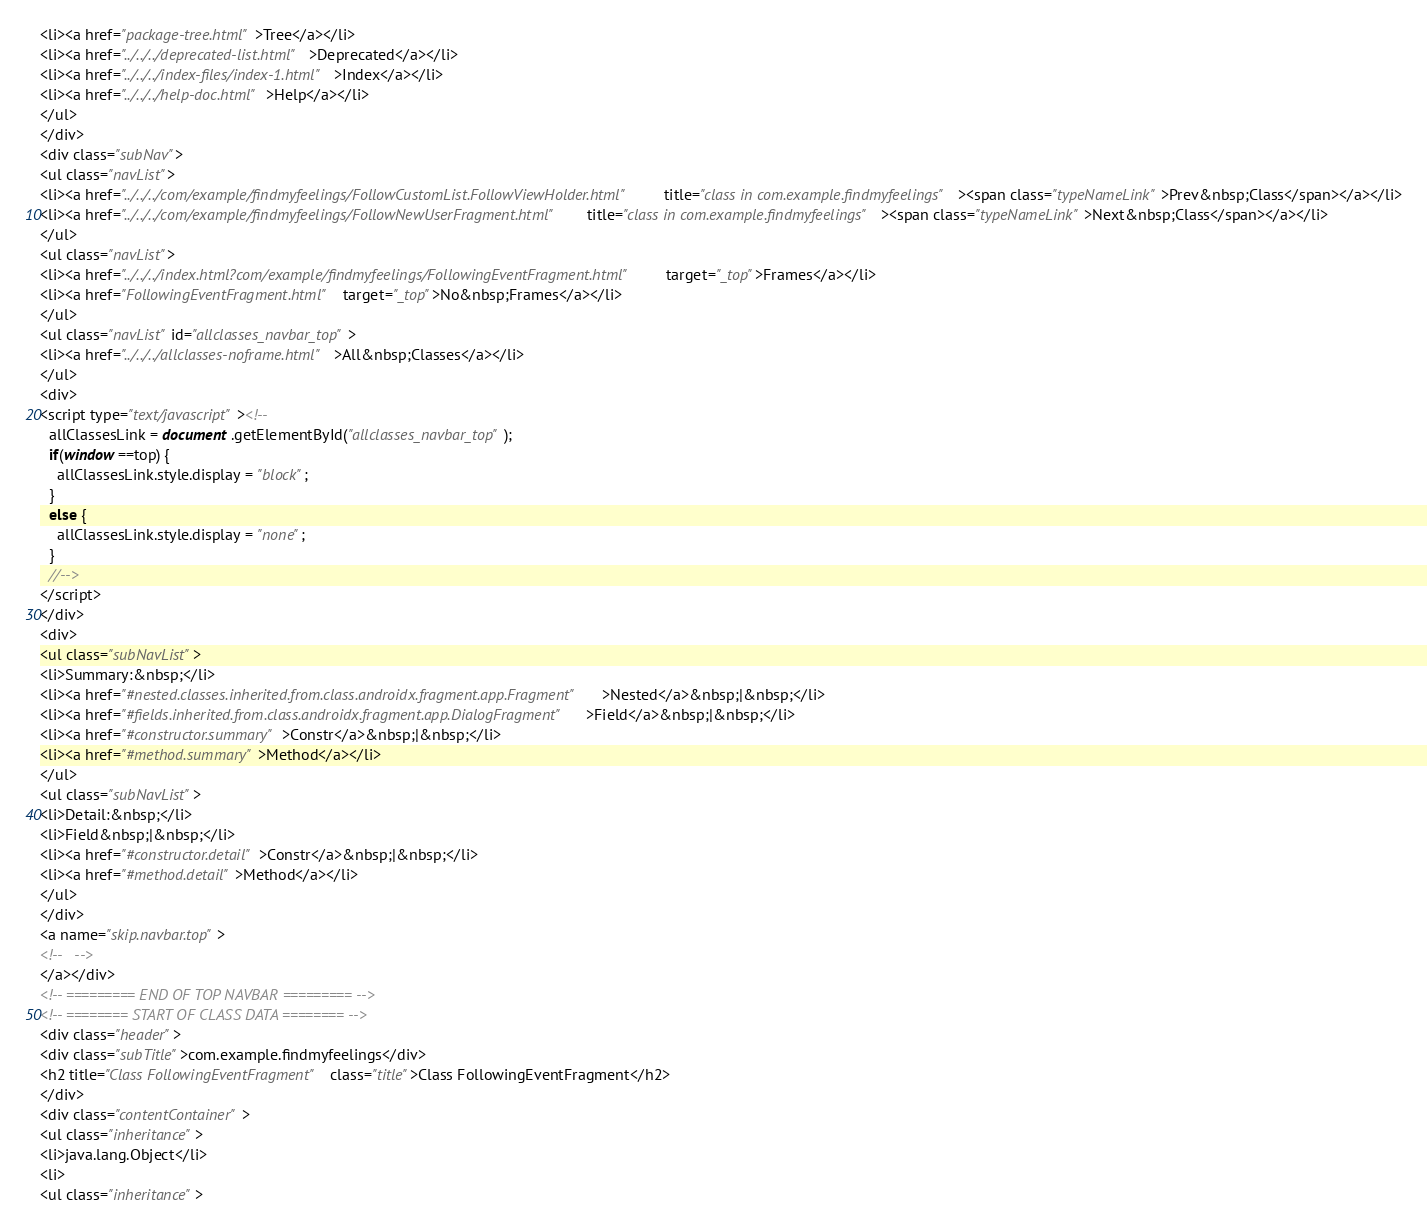Convert code to text. <code><loc_0><loc_0><loc_500><loc_500><_HTML_><li><a href="package-tree.html">Tree</a></li>
<li><a href="../../../deprecated-list.html">Deprecated</a></li>
<li><a href="../../../index-files/index-1.html">Index</a></li>
<li><a href="../../../help-doc.html">Help</a></li>
</ul>
</div>
<div class="subNav">
<ul class="navList">
<li><a href="../../../com/example/findmyfeelings/FollowCustomList.FollowViewHolder.html" title="class in com.example.findmyfeelings"><span class="typeNameLink">Prev&nbsp;Class</span></a></li>
<li><a href="../../../com/example/findmyfeelings/FollowNewUserFragment.html" title="class in com.example.findmyfeelings"><span class="typeNameLink">Next&nbsp;Class</span></a></li>
</ul>
<ul class="navList">
<li><a href="../../../index.html?com/example/findmyfeelings/FollowingEventFragment.html" target="_top">Frames</a></li>
<li><a href="FollowingEventFragment.html" target="_top">No&nbsp;Frames</a></li>
</ul>
<ul class="navList" id="allclasses_navbar_top">
<li><a href="../../../allclasses-noframe.html">All&nbsp;Classes</a></li>
</ul>
<div>
<script type="text/javascript"><!--
  allClassesLink = document.getElementById("allclasses_navbar_top");
  if(window==top) {
    allClassesLink.style.display = "block";
  }
  else {
    allClassesLink.style.display = "none";
  }
  //-->
</script>
</div>
<div>
<ul class="subNavList">
<li>Summary:&nbsp;</li>
<li><a href="#nested.classes.inherited.from.class.androidx.fragment.app.Fragment">Nested</a>&nbsp;|&nbsp;</li>
<li><a href="#fields.inherited.from.class.androidx.fragment.app.DialogFragment">Field</a>&nbsp;|&nbsp;</li>
<li><a href="#constructor.summary">Constr</a>&nbsp;|&nbsp;</li>
<li><a href="#method.summary">Method</a></li>
</ul>
<ul class="subNavList">
<li>Detail:&nbsp;</li>
<li>Field&nbsp;|&nbsp;</li>
<li><a href="#constructor.detail">Constr</a>&nbsp;|&nbsp;</li>
<li><a href="#method.detail">Method</a></li>
</ul>
</div>
<a name="skip.navbar.top">
<!--   -->
</a></div>
<!-- ========= END OF TOP NAVBAR ========= -->
<!-- ======== START OF CLASS DATA ======== -->
<div class="header">
<div class="subTitle">com.example.findmyfeelings</div>
<h2 title="Class FollowingEventFragment" class="title">Class FollowingEventFragment</h2>
</div>
<div class="contentContainer">
<ul class="inheritance">
<li>java.lang.Object</li>
<li>
<ul class="inheritance"></code> 